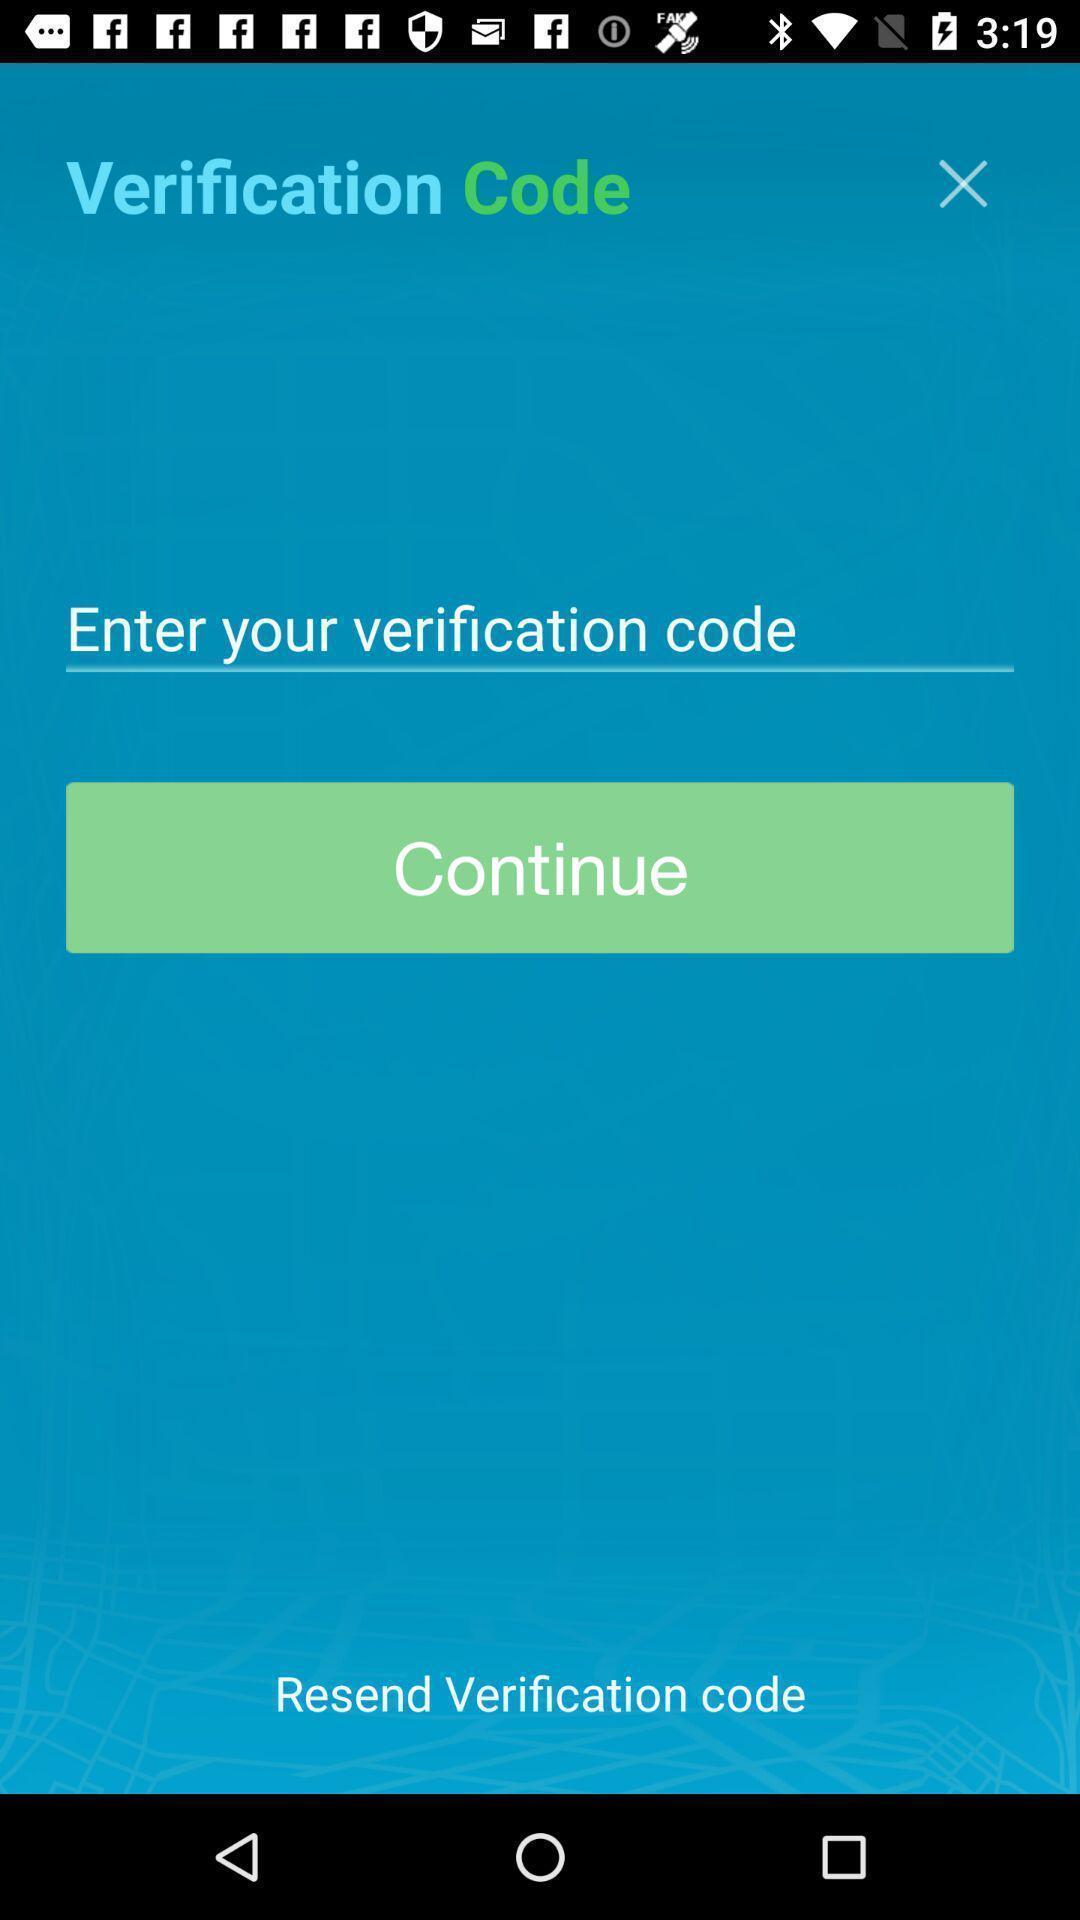Summarize the information in this screenshot. Page to enter verification code for using an app. 